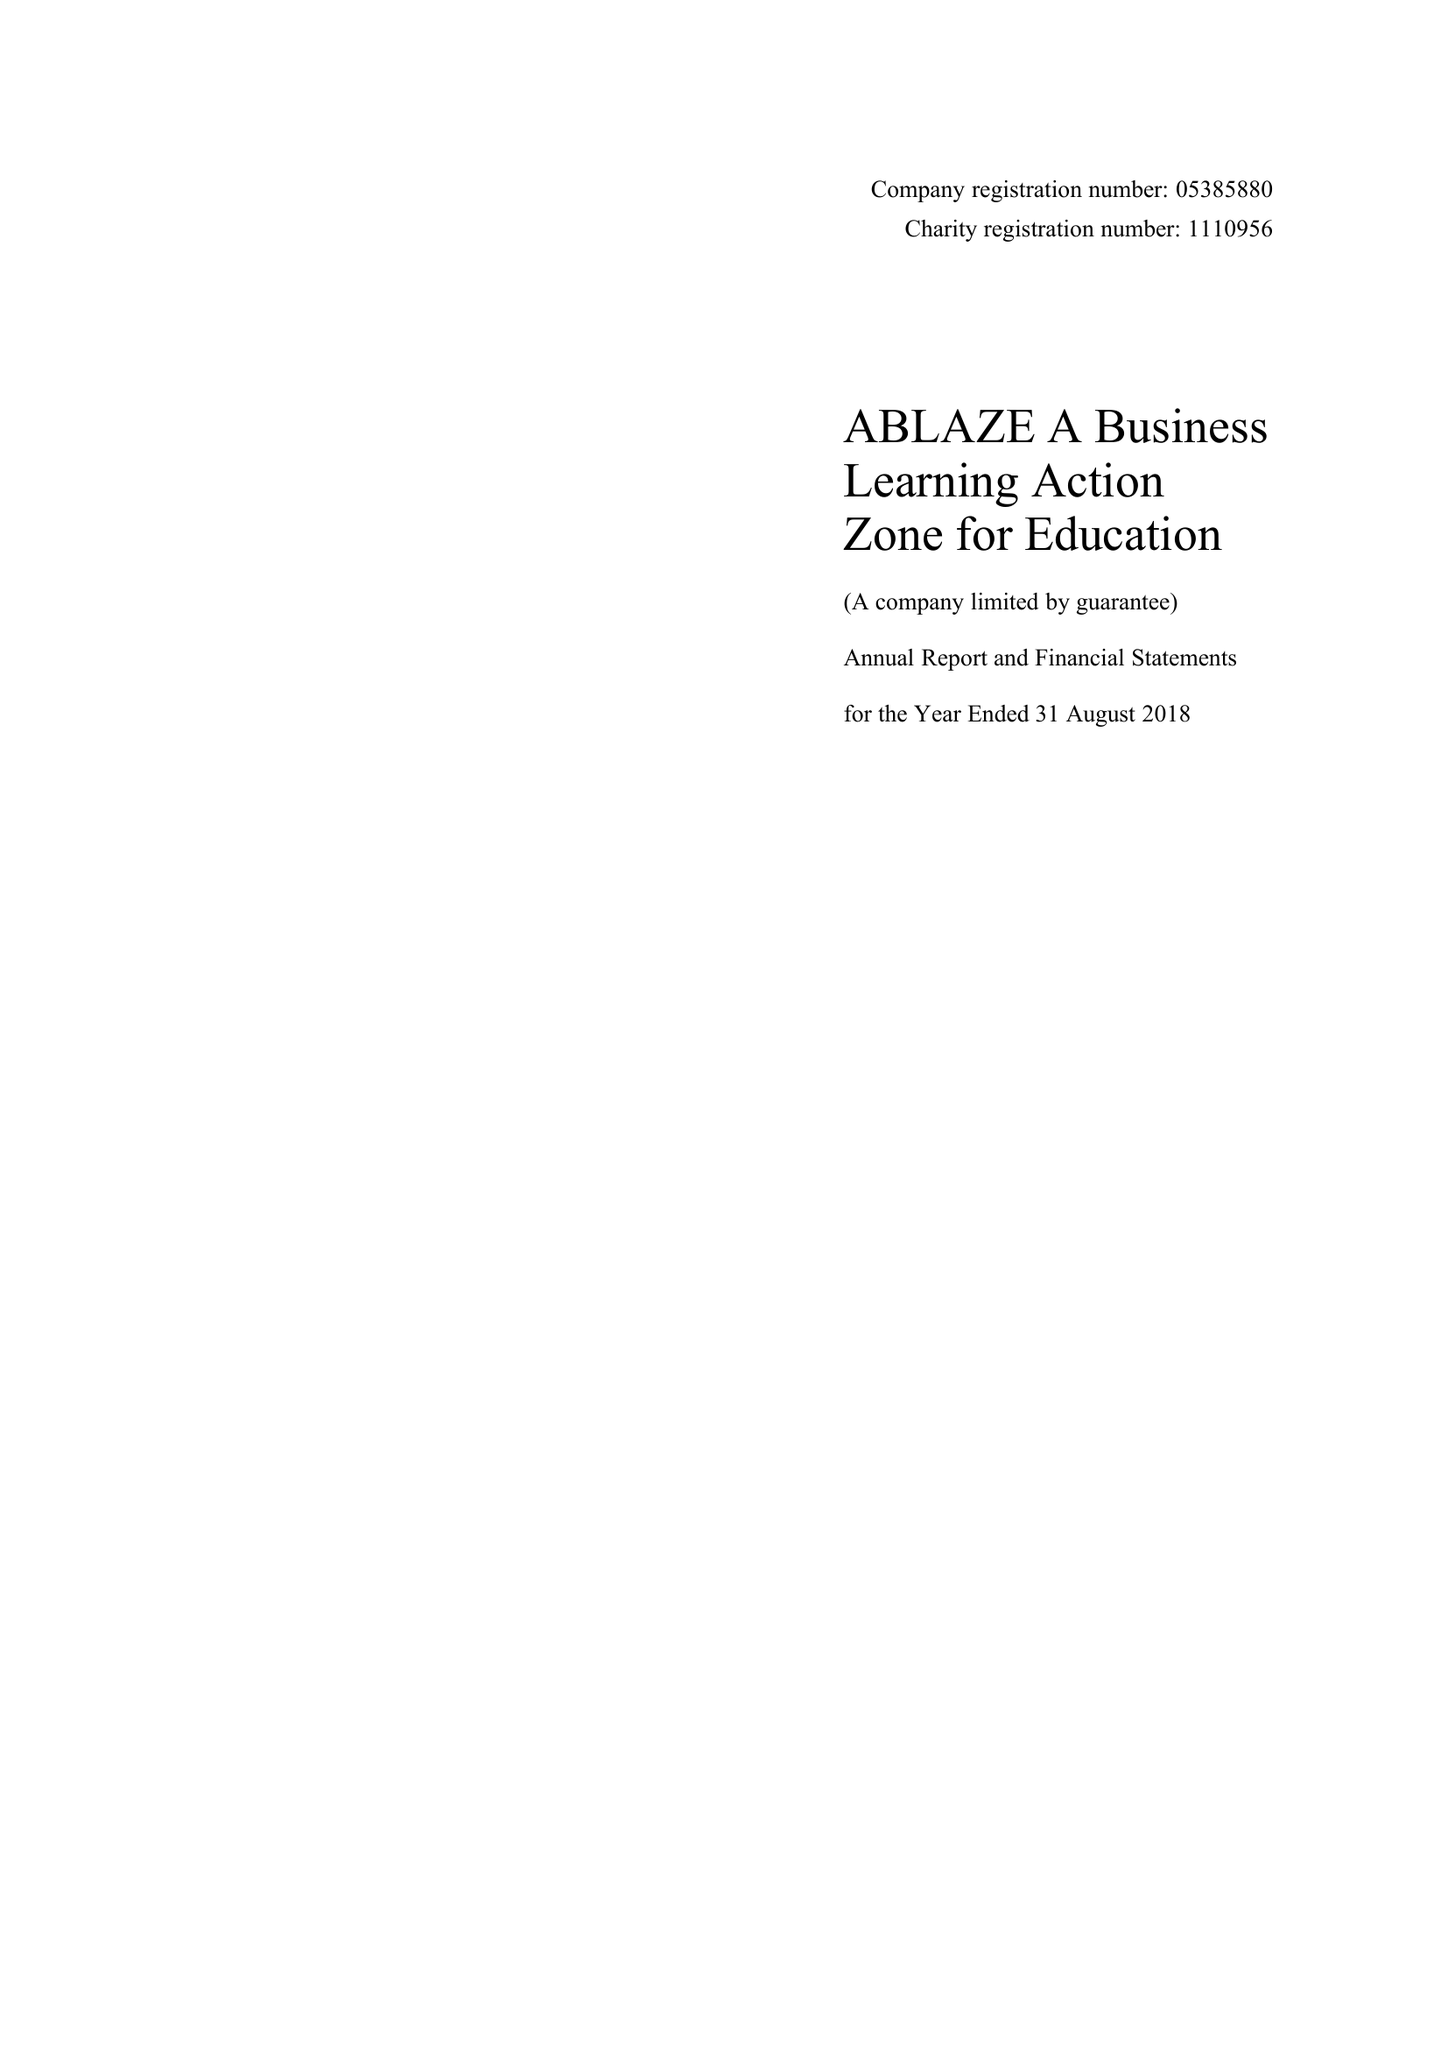What is the value for the report_date?
Answer the question using a single word or phrase. 2018-08-31 